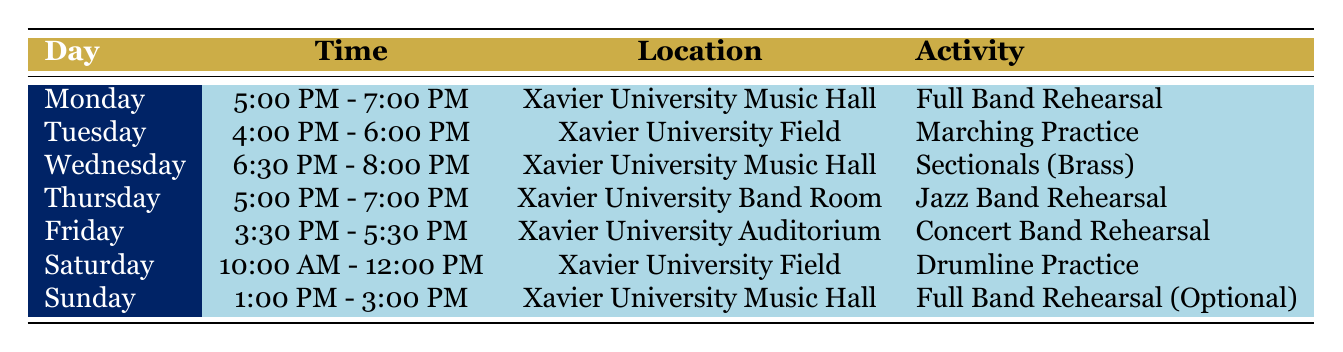What day is the Jazz Band Rehearsal scheduled? The table indicates that the Jazz Band Rehearsal occurs on Thursday.
Answer: Thursday What time does the Full Band Rehearsal (Optional) start on Sunday? According to the table, the Full Band Rehearsal (Optional) starts at 1:00 PM.
Answer: 1:00 PM Is there a rehearsal scheduled on Saturday? Yes, the table shows that there is a Drumline Practice scheduled from 10:00 AM to 12:00 PM on Saturday.
Answer: Yes How many total rehearsal sessions are held in the Xavier University Music Hall? By examining the table, there are three sessions in the Xavier University Music Hall: one on Monday (Full Band Rehearsal), one on Wednesday (Sectionals), and one on Sunday (Full Band Rehearsal Optional). Therefore, the total is 3.
Answer: 3 Which rehearsal has the latest start time in the week? The latest start time is on Wednesday at 6:30 PM for the Sectionals (Brass). None of the other rehearsals start later than this time.
Answer: Wednesday at 6:30 PM Are there any rehearsals that take place in the Xavier University Field? Yes, the table lists two rehearsals in the Xavier University Field: Marching Practice on Tuesday and Drumline Practice on Saturday.
Answer: Yes If the week consists of 7 days, what percentage of the week includes a rehearsal? There are 7 rehearsal sessions scheduled, covering all 7 days. To find the percentage, we use (7/7) * 100 = 100%. Thus, every day of the week has a rehearsal.
Answer: 100% What is the duration of the Concert Band Rehearsal on Friday? The table shows that the Concert Band Rehearsal occurs from 3:30 PM to 5:30 PM, which totals 2 hours.
Answer: 2 hours Which location is used for the Marching Practice? The table indicates that Marching Practice is held at the Xavier University Field.
Answer: Xavier University Field 